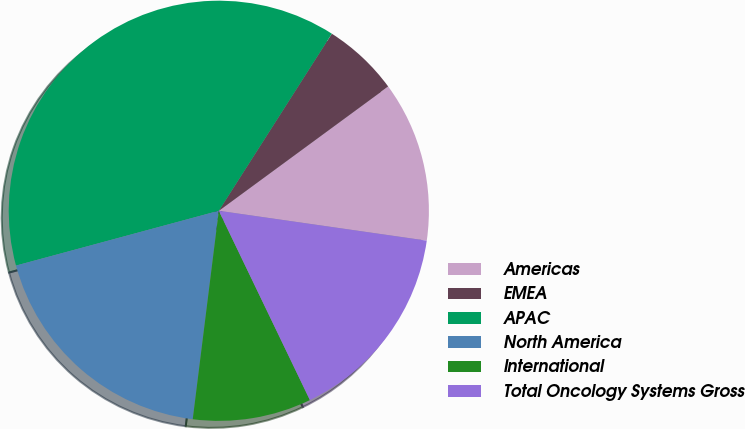Convert chart. <chart><loc_0><loc_0><loc_500><loc_500><pie_chart><fcel>Americas<fcel>EMEA<fcel>APAC<fcel>North America<fcel>International<fcel>Total Oncology Systems Gross<nl><fcel>12.35%<fcel>5.88%<fcel>38.24%<fcel>18.82%<fcel>9.12%<fcel>15.59%<nl></chart> 